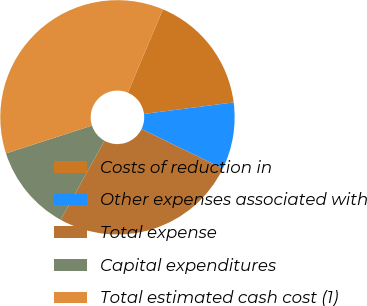<chart> <loc_0><loc_0><loc_500><loc_500><pie_chart><fcel>Costs of reduction in<fcel>Other expenses associated with<fcel>Total expense<fcel>Capital expenditures<fcel>Total estimated cash cost (1)<nl><fcel>16.63%<fcel>9.24%<fcel>25.86%<fcel>11.95%<fcel>36.33%<nl></chart> 